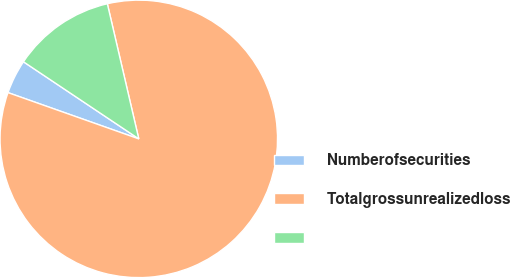Convert chart to OTSL. <chart><loc_0><loc_0><loc_500><loc_500><pie_chart><fcel>Numberofsecurities<fcel>Totalgrossunrealizedloss<fcel>Unnamed: 2<nl><fcel>3.97%<fcel>84.05%<fcel>11.98%<nl></chart> 